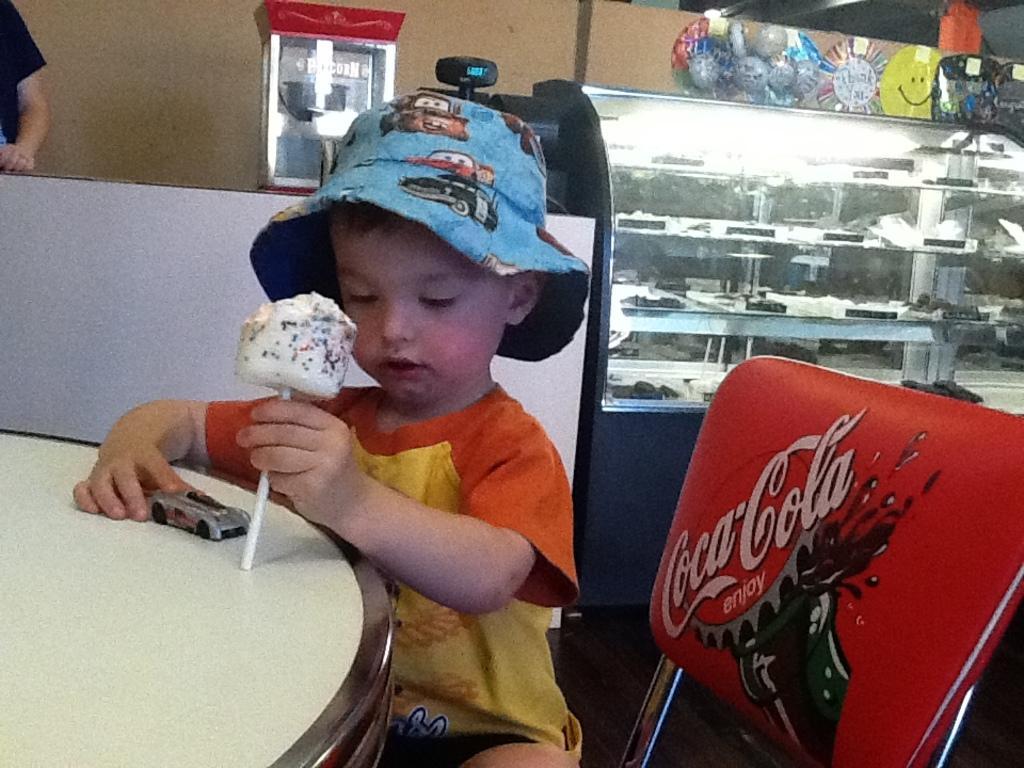Describe this image in one or two sentences. In this picture I can see a boy holding a candy in one hand and a small toy car in another hand and I can see a chair and a table and I can see a glass box and few balloons and looks like a human standing on the top left corner of the picture and the picture looks like a store. 